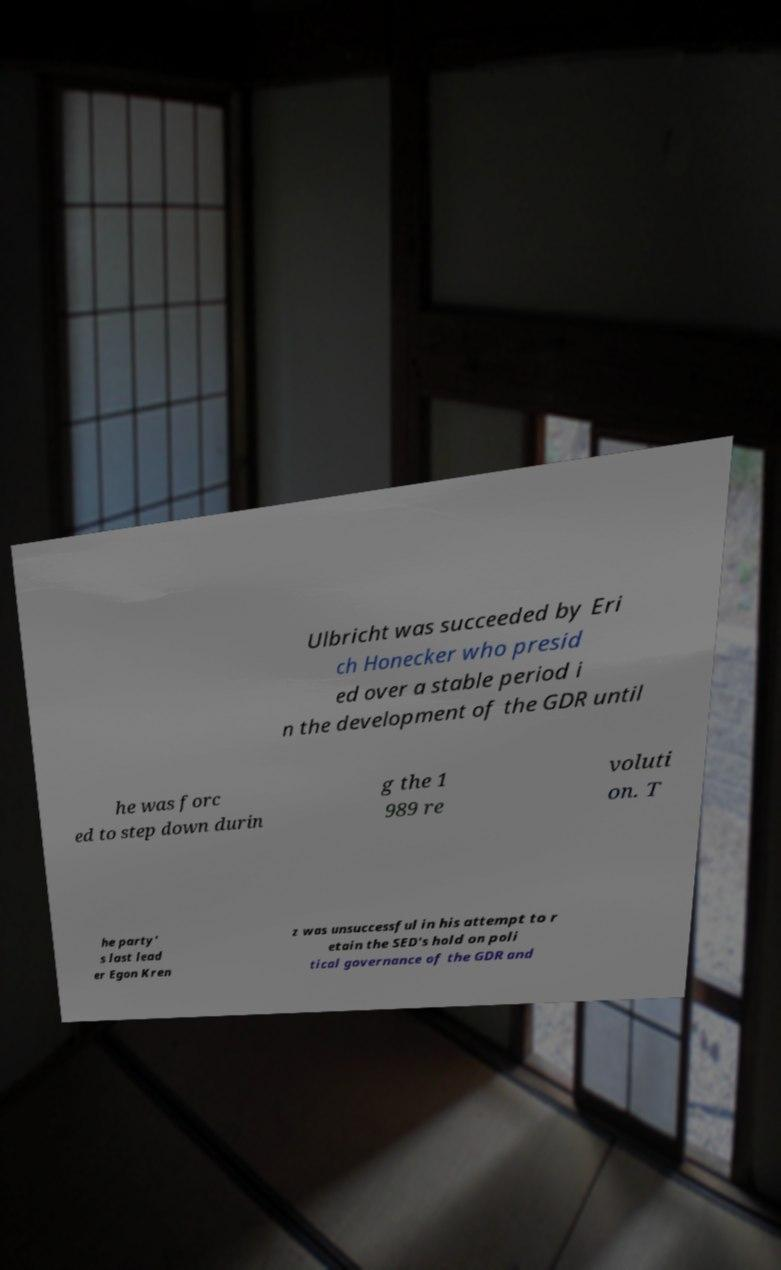I need the written content from this picture converted into text. Can you do that? Ulbricht was succeeded by Eri ch Honecker who presid ed over a stable period i n the development of the GDR until he was forc ed to step down durin g the 1 989 re voluti on. T he party' s last lead er Egon Kren z was unsuccessful in his attempt to r etain the SED's hold on poli tical governance of the GDR and 